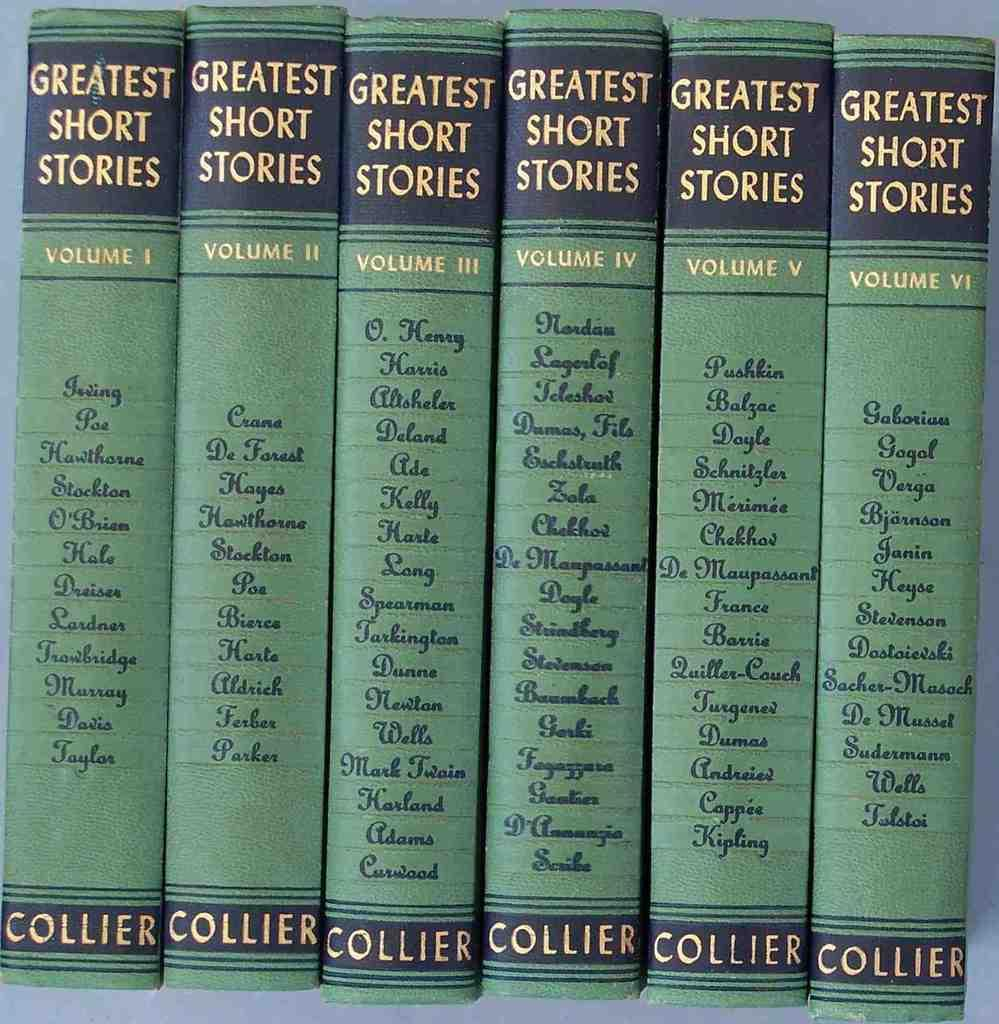<image>
Write a terse but informative summary of the picture. Several volumes of the greatest short stories are bound in green and lined up together. 